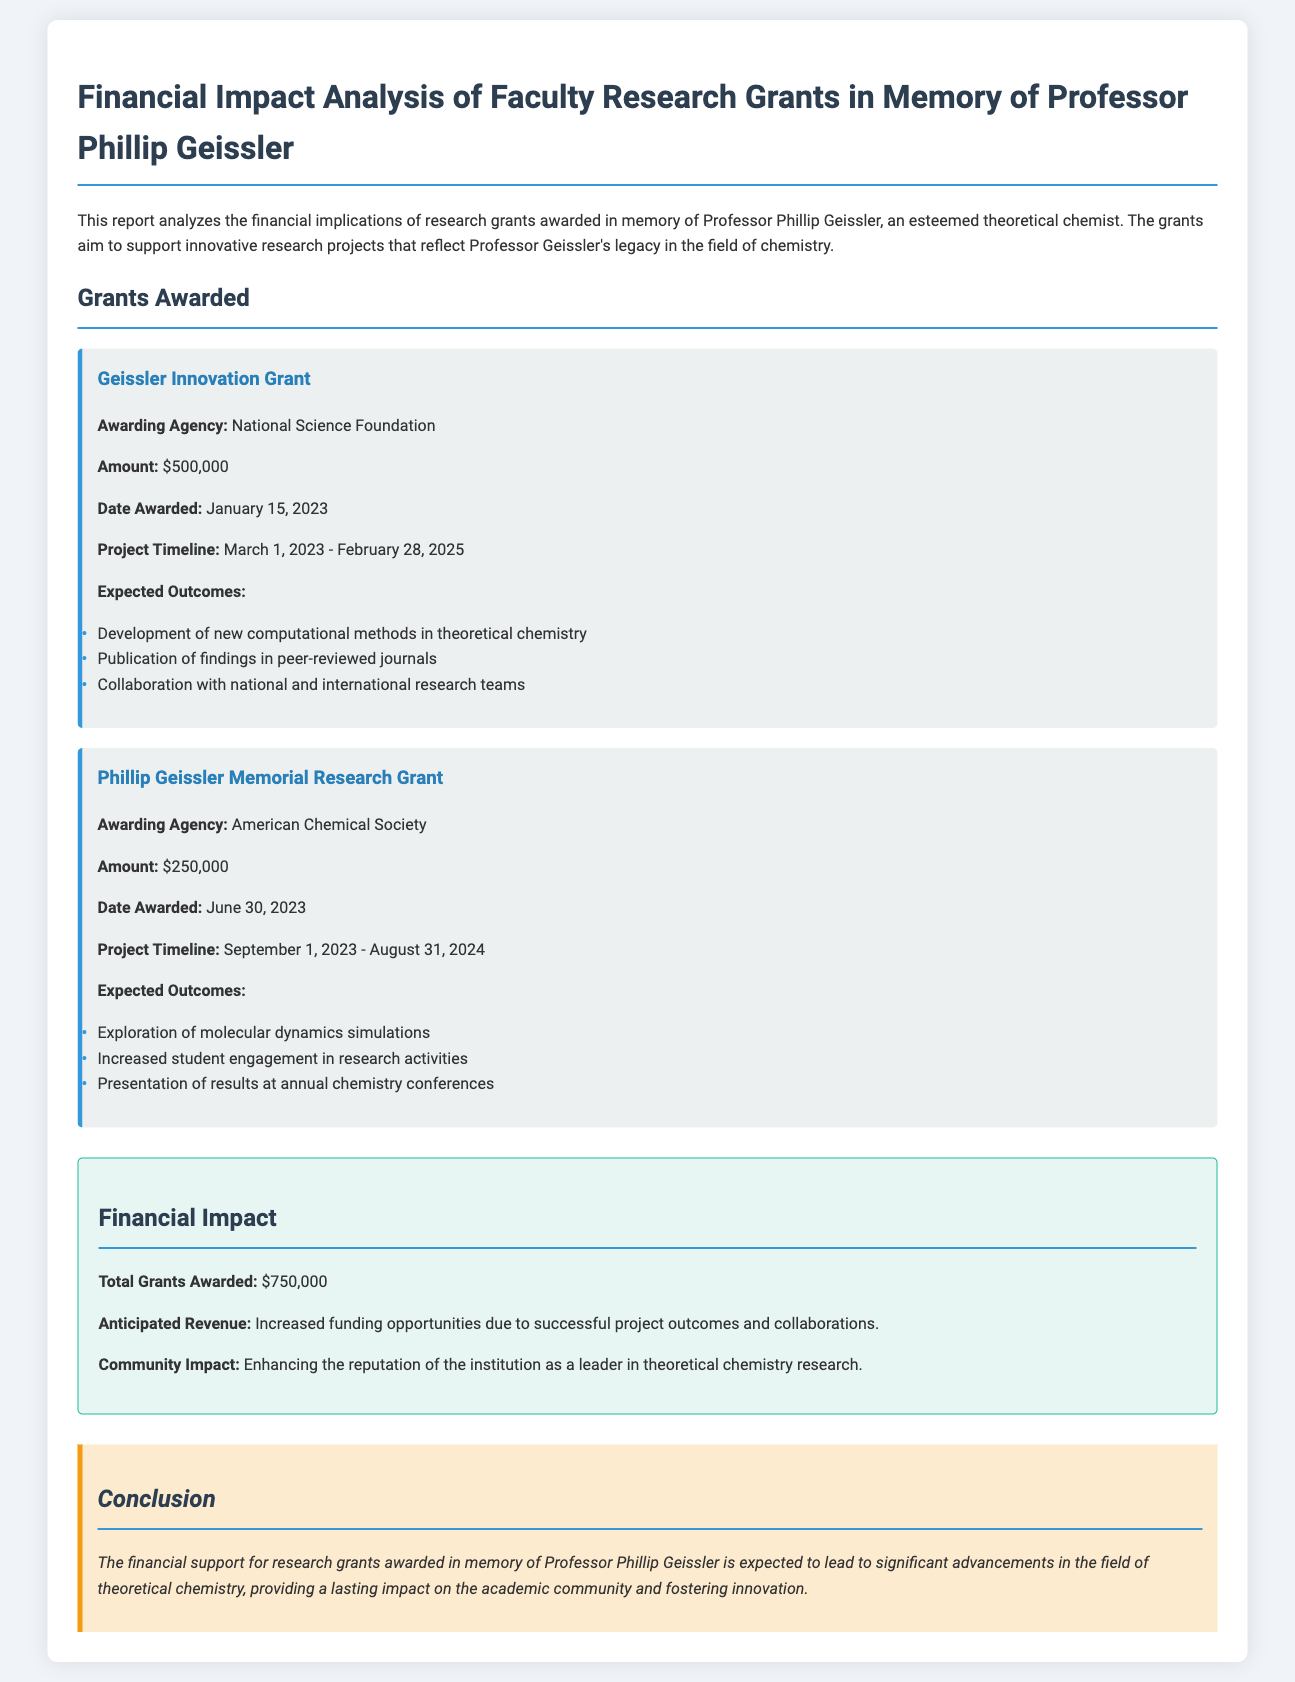What is the title of the report? The title of the report is stated at the beginning and is focused on the financial impact analysis of grants awarded in memory of Professor Phillip Geissler.
Answer: Financial Impact Analysis of Faculty Research Grants in Memory of Professor Phillip Geissler What is the amount of the Geissler Innovation Grant? The amount awarded for the Geissler Innovation Grant is specified in the document.
Answer: $500,000 When was the Phillip Geissler Memorial Research Grant awarded? The date awarded for the Phillip Geissler Memorial Research Grant is given in the report.
Answer: June 30, 2023 What is the project timeline for the Geissler Innovation Grant? The project timeline is clearly mentioned for the Geissler Innovation Grant in the document.
Answer: March 1, 2023 - February 28, 2025 What are the expected outcomes of the Phillip Geissler Memorial Research Grant? The expected outcomes are listed for the Phillip Geissler Memorial Research Grant, providing insights into the project's goals.
Answer: Exploration of molecular dynamics simulations, Increased student engagement in research activities, Presentation of results at annual chemistry conferences What is the total amount of grants awarded? The total amount of grants awarded is summarized in the financial impact section of the document.
Answer: $750,000 What kind of impact is anticipated from the grants? The anticipated impact is described in terms of financial and community benefits within the financial impact section.
Answer: Increased funding opportunities due to successful project outcomes and collaborations What agency awarded the Geissler Innovation Grant? The awarding agency for the Geissler Innovation Grant is provided in the details of the grant section.
Answer: National Science Foundation 